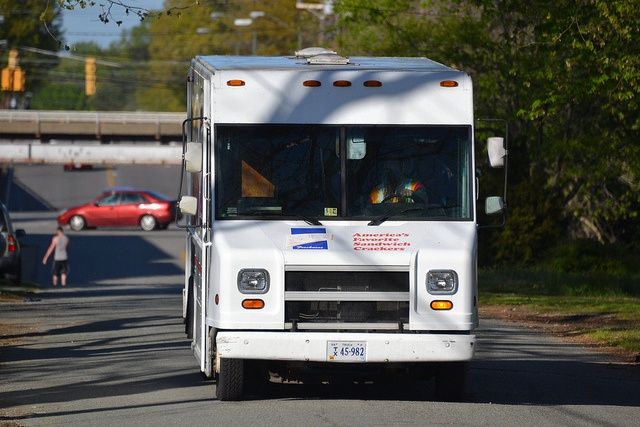Describe the objects in this image and their specific colors. I can see truck in black, lightgray, darkgray, and gray tones, car in black, maroon, salmon, brown, and gray tones, people in black, maroon, gray, and brown tones, car in black, gray, and maroon tones, and people in black and gray tones in this image. 